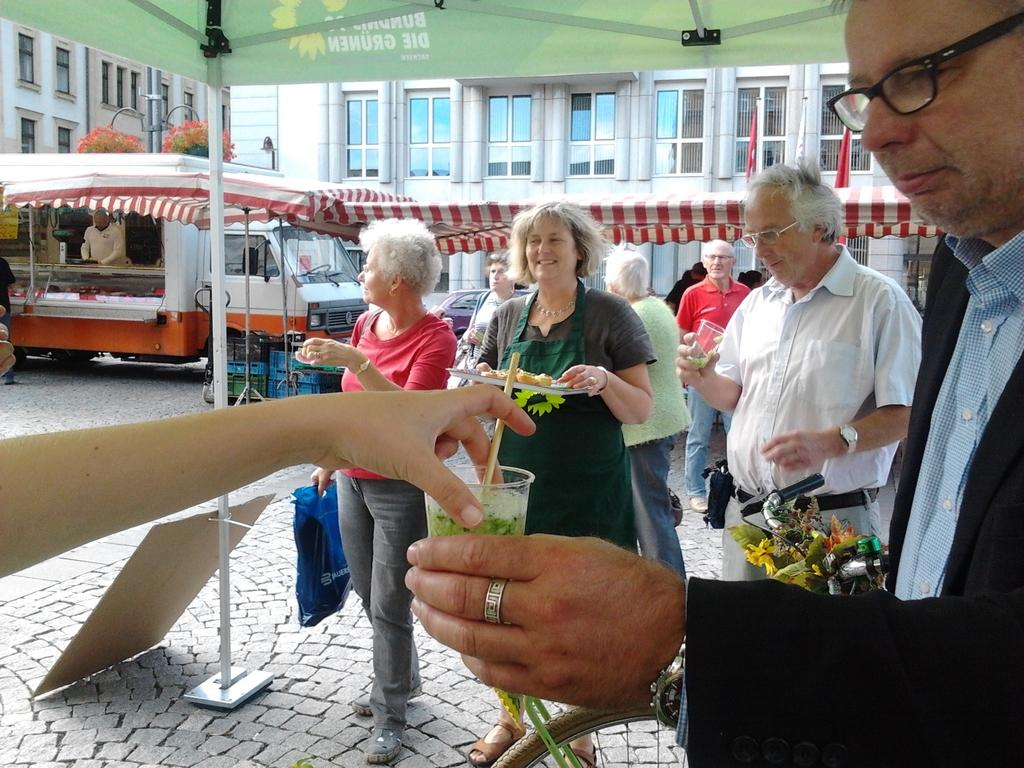How many people are in the image? There is a group of people in the image. What are the people doing in the image? The people are standing together and holding junk food. Where are the food stalls located in the image? The food stalls are under a tent in the image. What can be seen in the background of the image? There are buildings visible in the background of the image. How many arms does the station have in the image? There is no station present in the image, and therefore no arms can be attributed to it. 